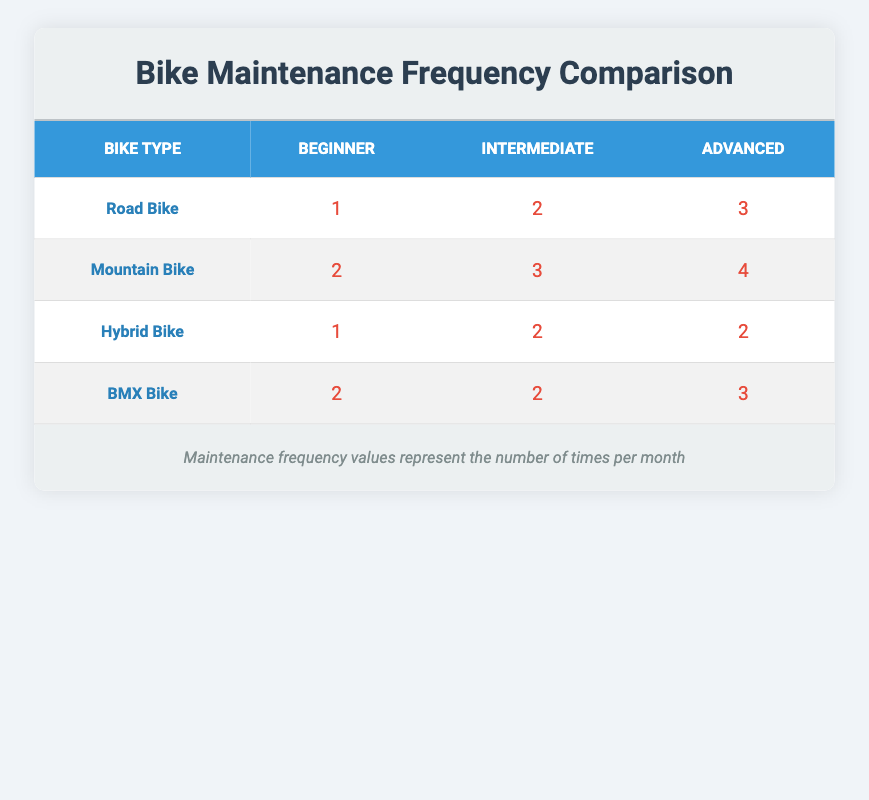What is the maintenance frequency for beginners using a Road Bike? The table shows that for the Road Bike under the Beginner category, the maintenance frequency is listed as 1 per month.
Answer: 1 How many times per month does an Advanced user typically maintain a Mountain Bike? According to the table, the maintenance frequency for Advanced users of Mountain Bikes is shown as 4 per month.
Answer: 4 Which type of bike requires the most frequent maintenance for Intermediate users? By comparing the values in the Intermediate column, Mountain Bikes (3) have the highest maintenance frequency compared to Road Bikes (2), Hybrid Bikes (2), and BMX Bikes (2).
Answer: Mountain Bike Is it true that Hybrid Bike users at an Advanced level require more maintenance than Road Bike users at the same level? Checking the Advanced levels for both bike types reveals that Hybrid Bike users maintain their bikes 2 times per month, whereas Road Bike users do 3 times. Thus, this statement is false.
Answer: No What is the average maintenance frequency for all bike types among Intermediate users? To find the average, we sum the values for Intermediate users: 2 (Road) + 3 (Mountain) + 2 (Hybrid) + 2 (BMX) = 9. There are 4 bike types, so the average is 9/4 = 2.25.
Answer: 2.25 For which experience level is the maintenance frequency highest across all bike types? We analyze the values across all bike types: Advanced users maintain at 3 (Road), 4 (Mountain), 2 (Hybrid), and 3 (BMX). The highest frequency is 4 for Advanced Mountain Bike users.
Answer: Advanced What is the difference in maintenance frequency between Intermediate and Advanced users for BMX Bikes? The Intermediate maintenance frequency for BMX Bikes is 2, while the Advanced frequency is 3. Therefore, the difference is 3 - 2 = 1.
Answer: 1 Do all types of bikes have the same maintenance frequency for Beginner users? Observing the Beginner users, Road Bikes (1), Mountain Bikes (2), Hybrid Bikes (1), and BMX Bikes (2) shows that they do not all have the same frequency. Thus, this statement is false.
Answer: No How many total maintenance occurrences would a Beginner using a Mountain Bike and an Advanced using a Road Bike have in a month? The Beginner using a Mountain Bike maintains it 2 times, and the Advanced user of a Road Bike maintains it 3 times. So the total is 2 + 3 = 5.
Answer: 5 